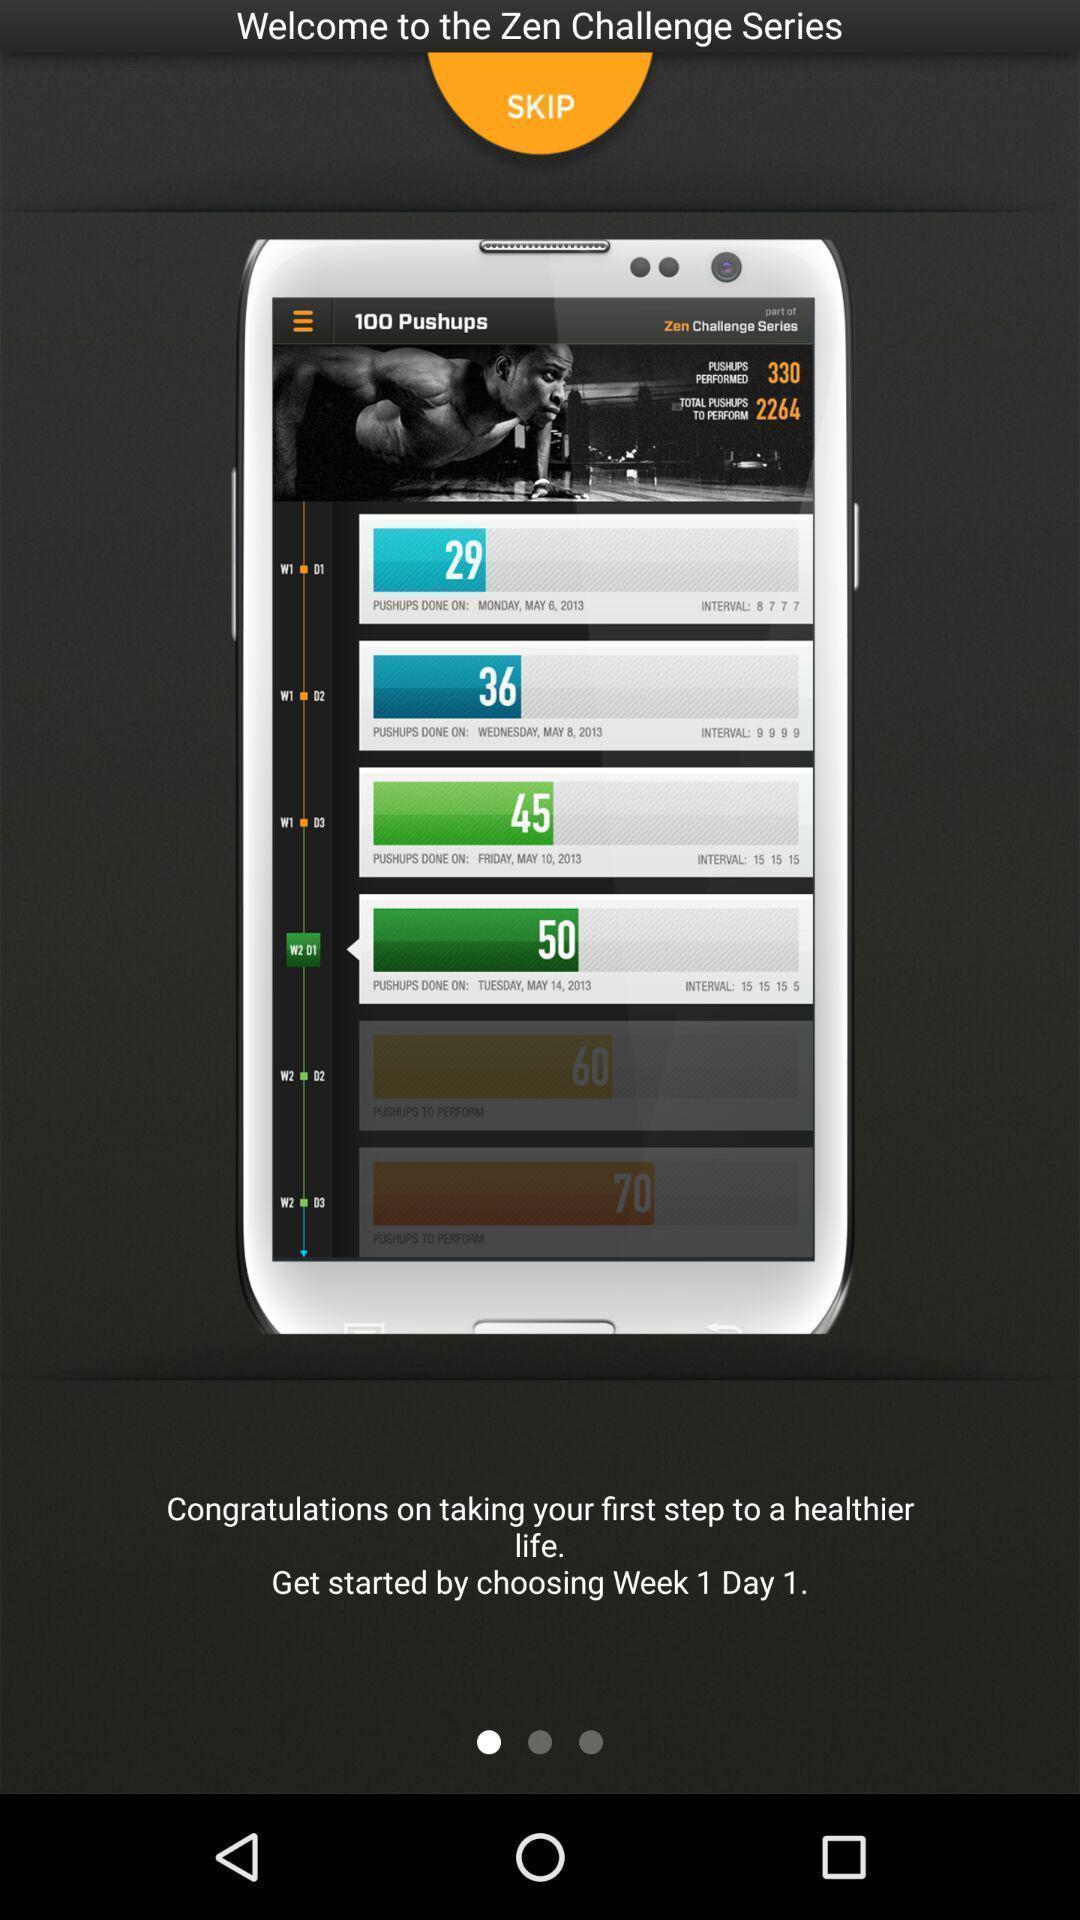Tell me what you see in this picture. Welcome page to start with the app. 